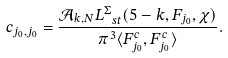Convert formula to latex. <formula><loc_0><loc_0><loc_500><loc_500>c _ { j _ { 0 } , j _ { 0 } } = \frac { \mathcal { A } _ { k , N } L _ { \ s t } ^ { \Sigma } ( 5 - k , F _ { j _ { 0 } } , \chi ) } { \pi ^ { 3 } \langle F _ { j _ { 0 } } ^ { c } , F _ { j _ { 0 } } ^ { c } \rangle } .</formula> 